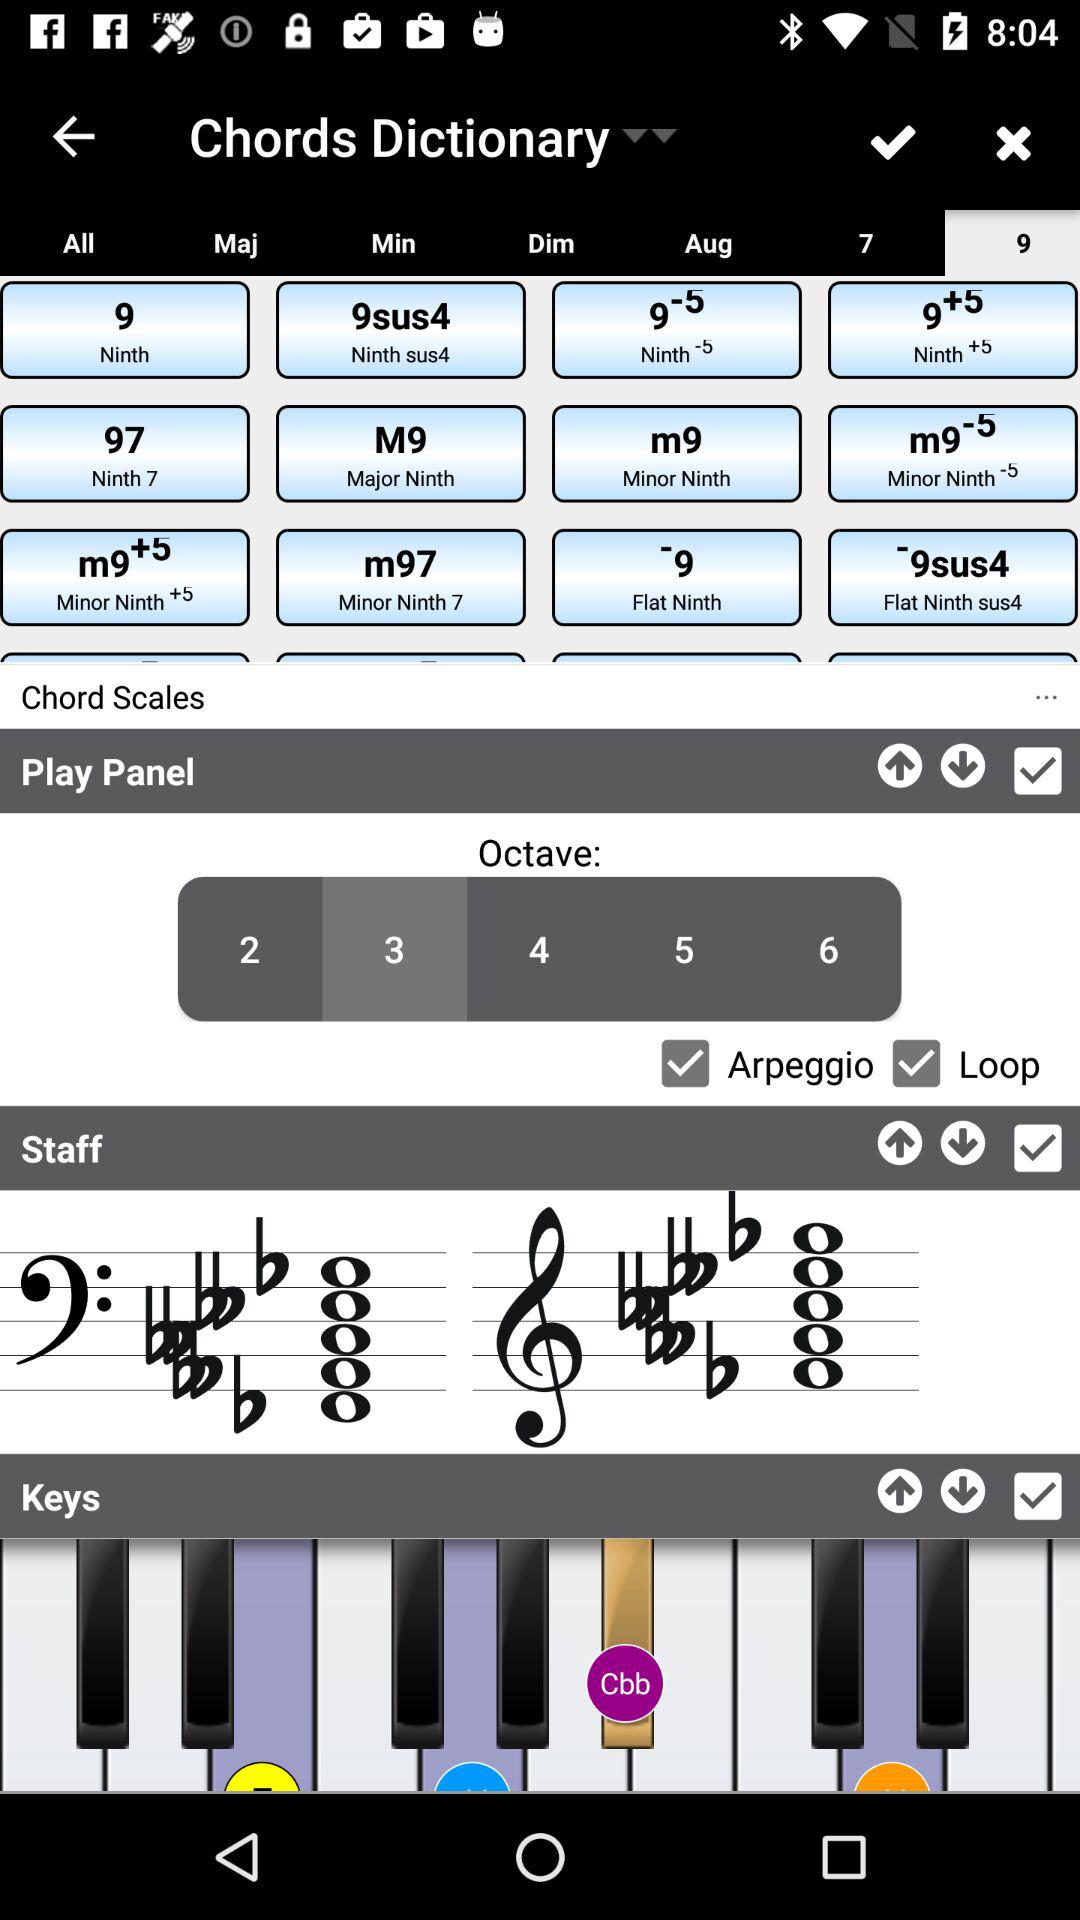What is the status of "Play Panel"? The status of "Play Panel" is "on". 